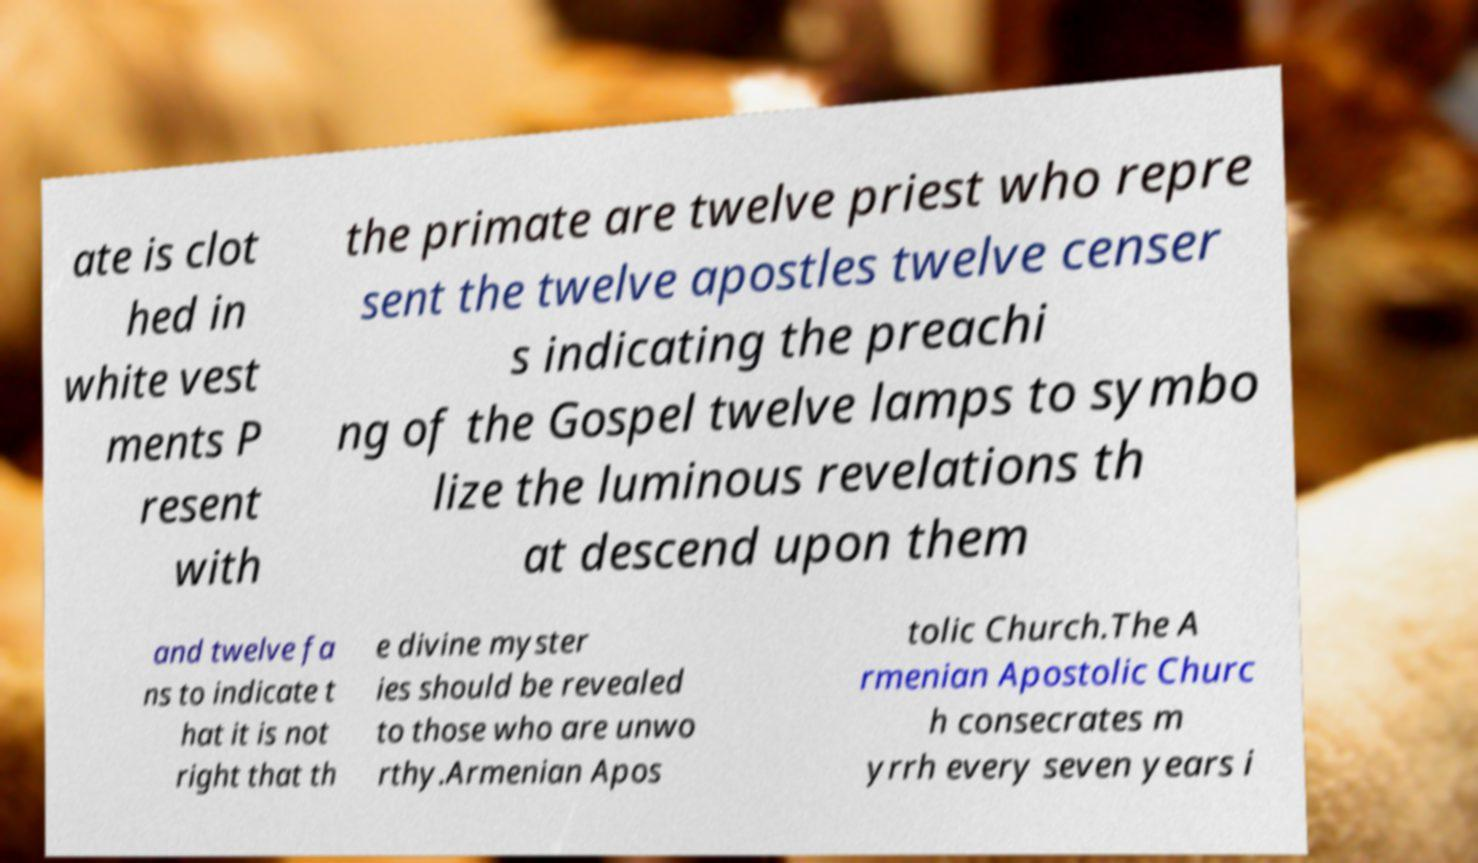Could you extract and type out the text from this image? ate is clot hed in white vest ments P resent with the primate are twelve priest who repre sent the twelve apostles twelve censer s indicating the preachi ng of the Gospel twelve lamps to symbo lize the luminous revelations th at descend upon them and twelve fa ns to indicate t hat it is not right that th e divine myster ies should be revealed to those who are unwo rthy.Armenian Apos tolic Church.The A rmenian Apostolic Churc h consecrates m yrrh every seven years i 